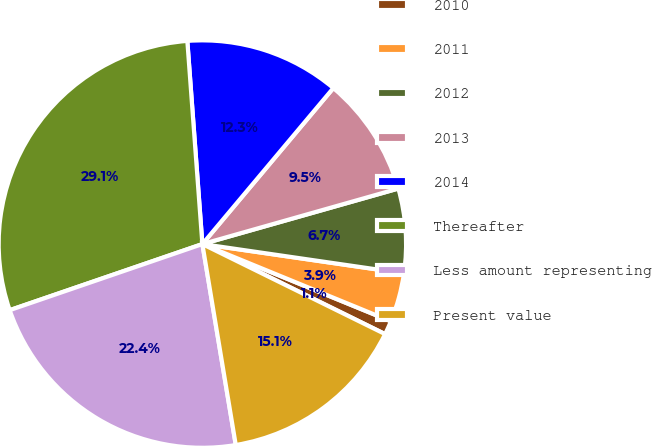<chart> <loc_0><loc_0><loc_500><loc_500><pie_chart><fcel>2010<fcel>2011<fcel>2012<fcel>2013<fcel>2014<fcel>Thereafter<fcel>Less amount representing<fcel>Present value<nl><fcel>1.1%<fcel>3.89%<fcel>6.69%<fcel>9.49%<fcel>12.29%<fcel>29.08%<fcel>22.36%<fcel>15.09%<nl></chart> 